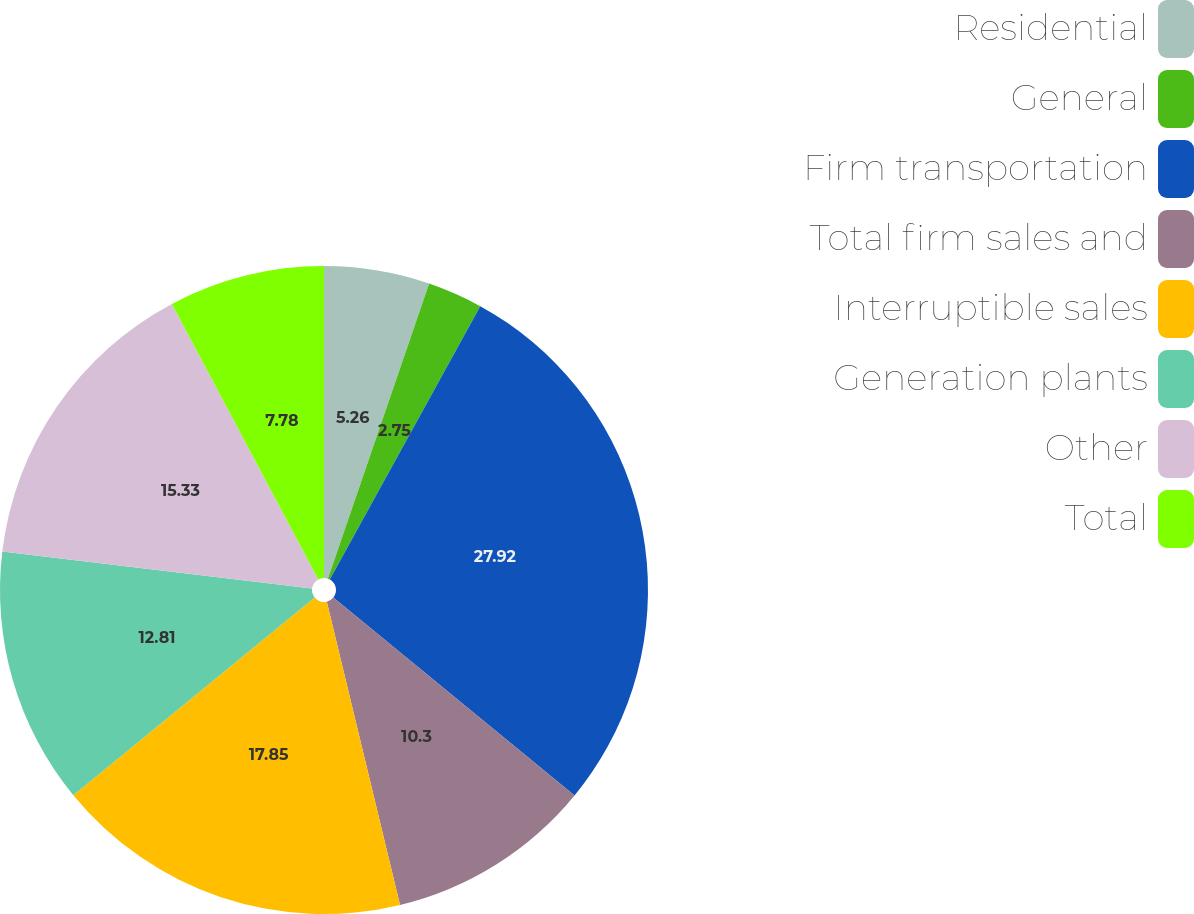Convert chart. <chart><loc_0><loc_0><loc_500><loc_500><pie_chart><fcel>Residential<fcel>General<fcel>Firm transportation<fcel>Total firm sales and<fcel>Interruptible sales<fcel>Generation plants<fcel>Other<fcel>Total<nl><fcel>5.26%<fcel>2.75%<fcel>27.92%<fcel>10.3%<fcel>17.85%<fcel>12.81%<fcel>15.33%<fcel>7.78%<nl></chart> 